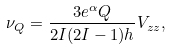Convert formula to latex. <formula><loc_0><loc_0><loc_500><loc_500>\nu _ { Q } = \frac { 3 e ^ { \alpha } Q } { 2 I ( 2 I - 1 ) h } V _ { z z } ,</formula> 